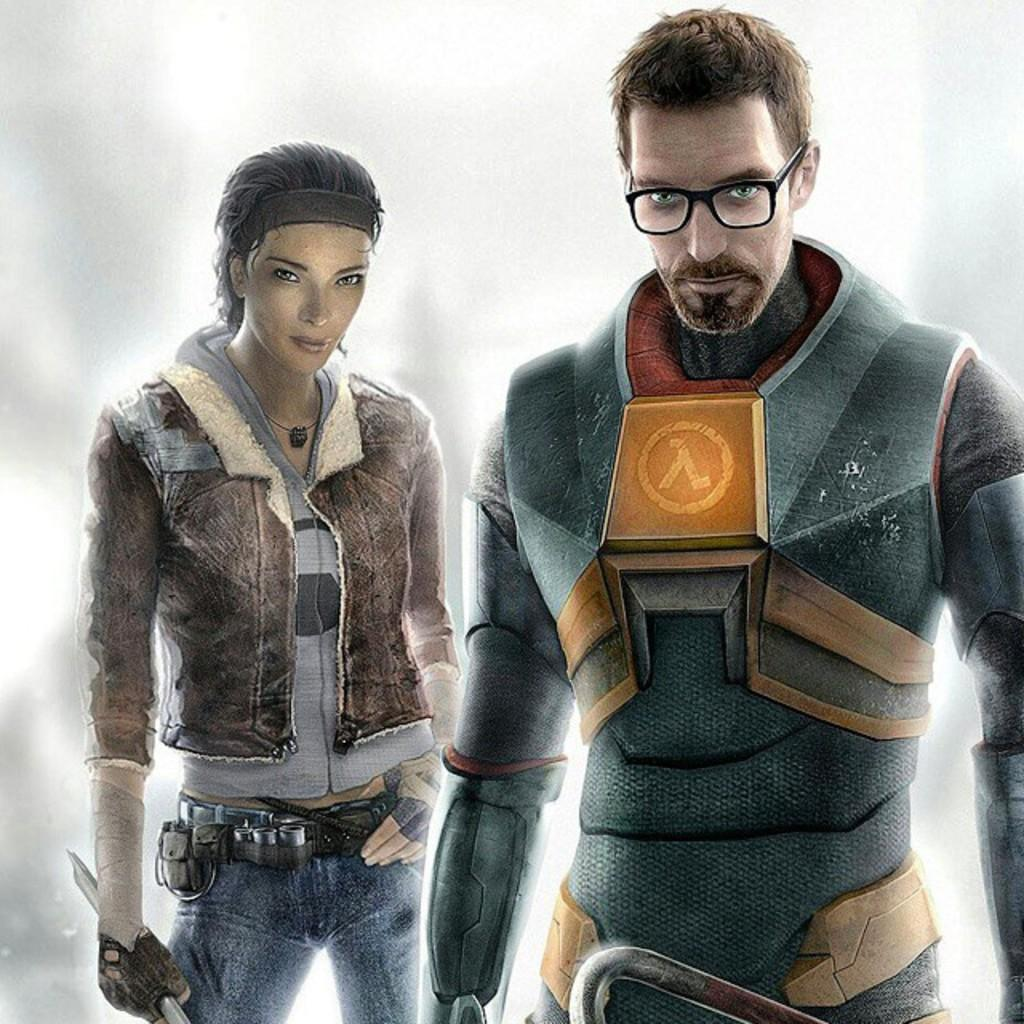What type of image is being described? The image is animated. How many people are present in the image? There are 2 people standing in the image. Can you describe the background of the image? The background of the image is blurred. What type of pies are being served by the kittens in the image? There are no kittens or pies present in the image; it is an animated scene with 2 people standing in it. 